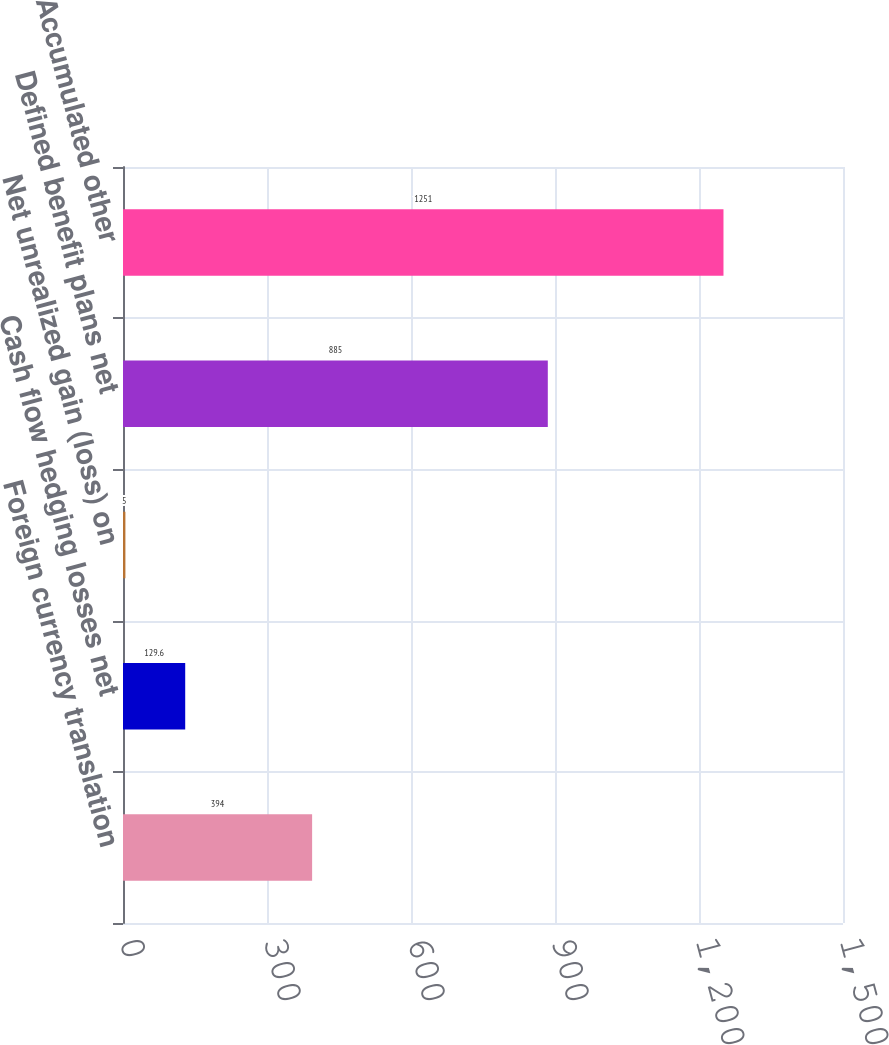Convert chart. <chart><loc_0><loc_0><loc_500><loc_500><bar_chart><fcel>Foreign currency translation<fcel>Cash flow hedging losses net<fcel>Net unrealized gain (loss) on<fcel>Defined benefit plans net<fcel>Accumulated other<nl><fcel>394<fcel>129.6<fcel>5<fcel>885<fcel>1251<nl></chart> 